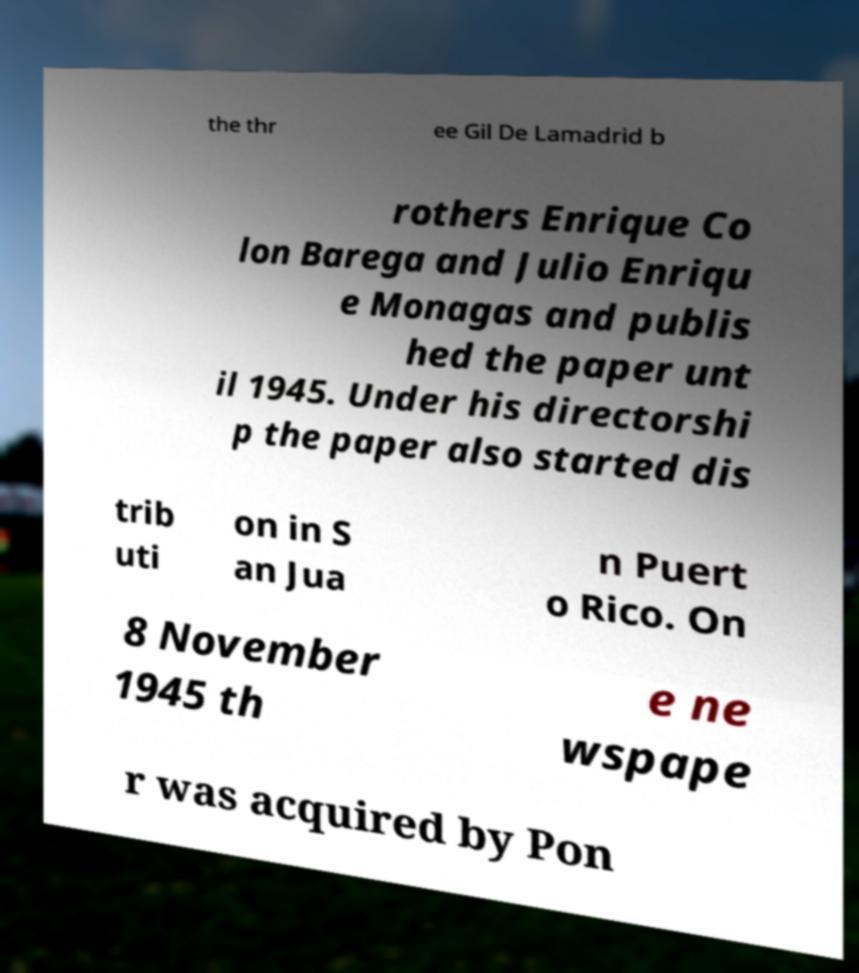Could you assist in decoding the text presented in this image and type it out clearly? the thr ee Gil De Lamadrid b rothers Enrique Co lon Barega and Julio Enriqu e Monagas and publis hed the paper unt il 1945. Under his directorshi p the paper also started dis trib uti on in S an Jua n Puert o Rico. On 8 November 1945 th e ne wspape r was acquired by Pon 